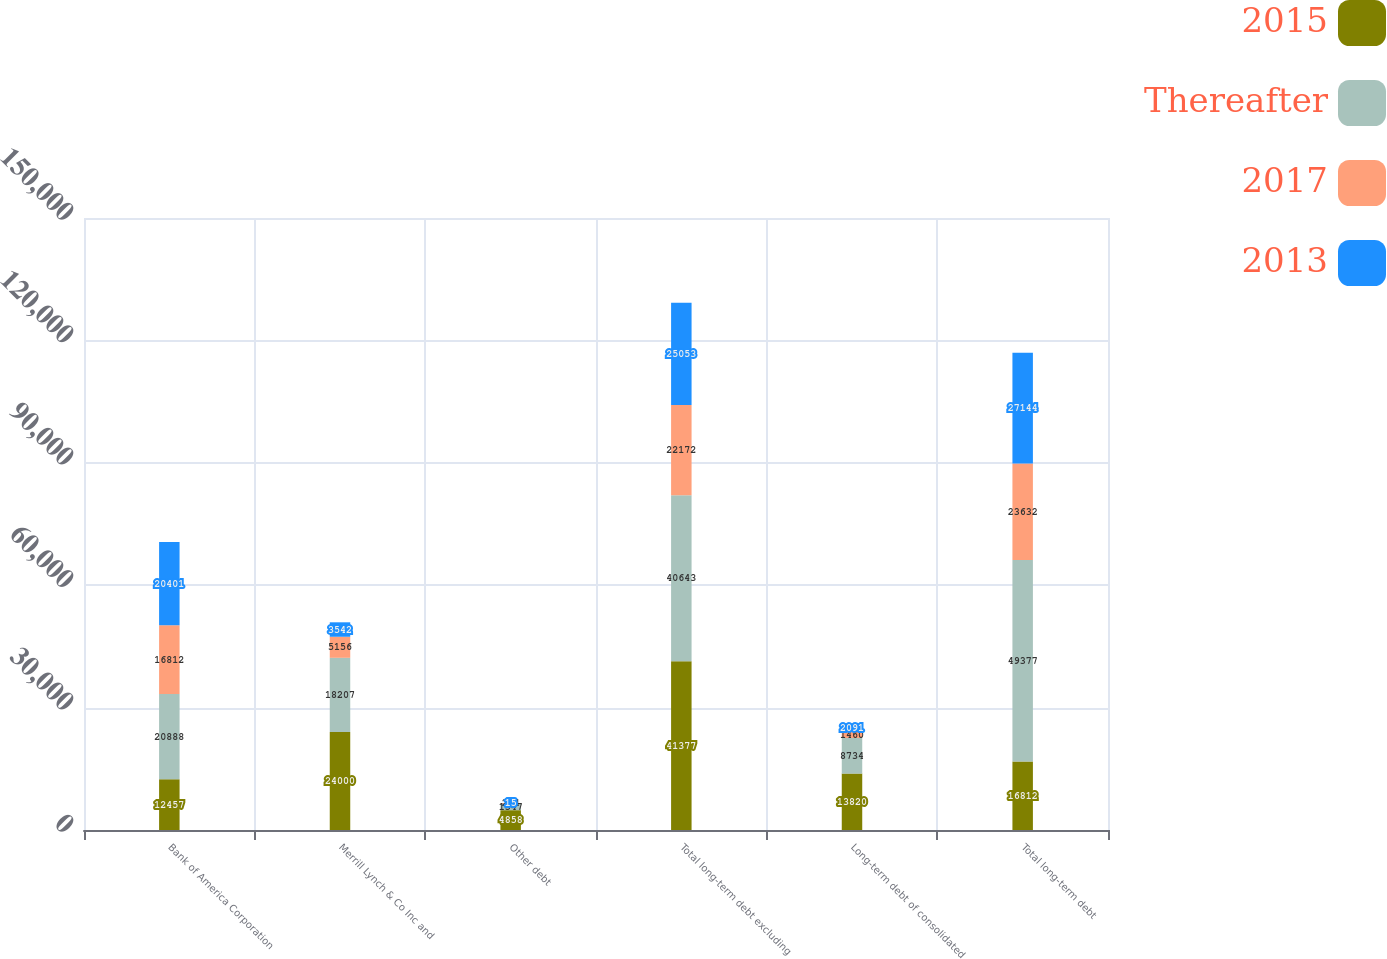Convert chart to OTSL. <chart><loc_0><loc_0><loc_500><loc_500><stacked_bar_chart><ecel><fcel>Bank of America Corporation<fcel>Merrill Lynch & Co Inc and<fcel>Other debt<fcel>Total long-term debt excluding<fcel>Long-term debt of consolidated<fcel>Total long-term debt<nl><fcel>2015<fcel>12457<fcel>24000<fcel>4858<fcel>41377<fcel>13820<fcel>16812<nl><fcel>Thereafter<fcel>20888<fcel>18207<fcel>1547<fcel>40643<fcel>8734<fcel>49377<nl><fcel>2017<fcel>16812<fcel>5156<fcel>204<fcel>22172<fcel>1460<fcel>23632<nl><fcel>2013<fcel>20401<fcel>3542<fcel>15<fcel>25053<fcel>2091<fcel>27144<nl></chart> 